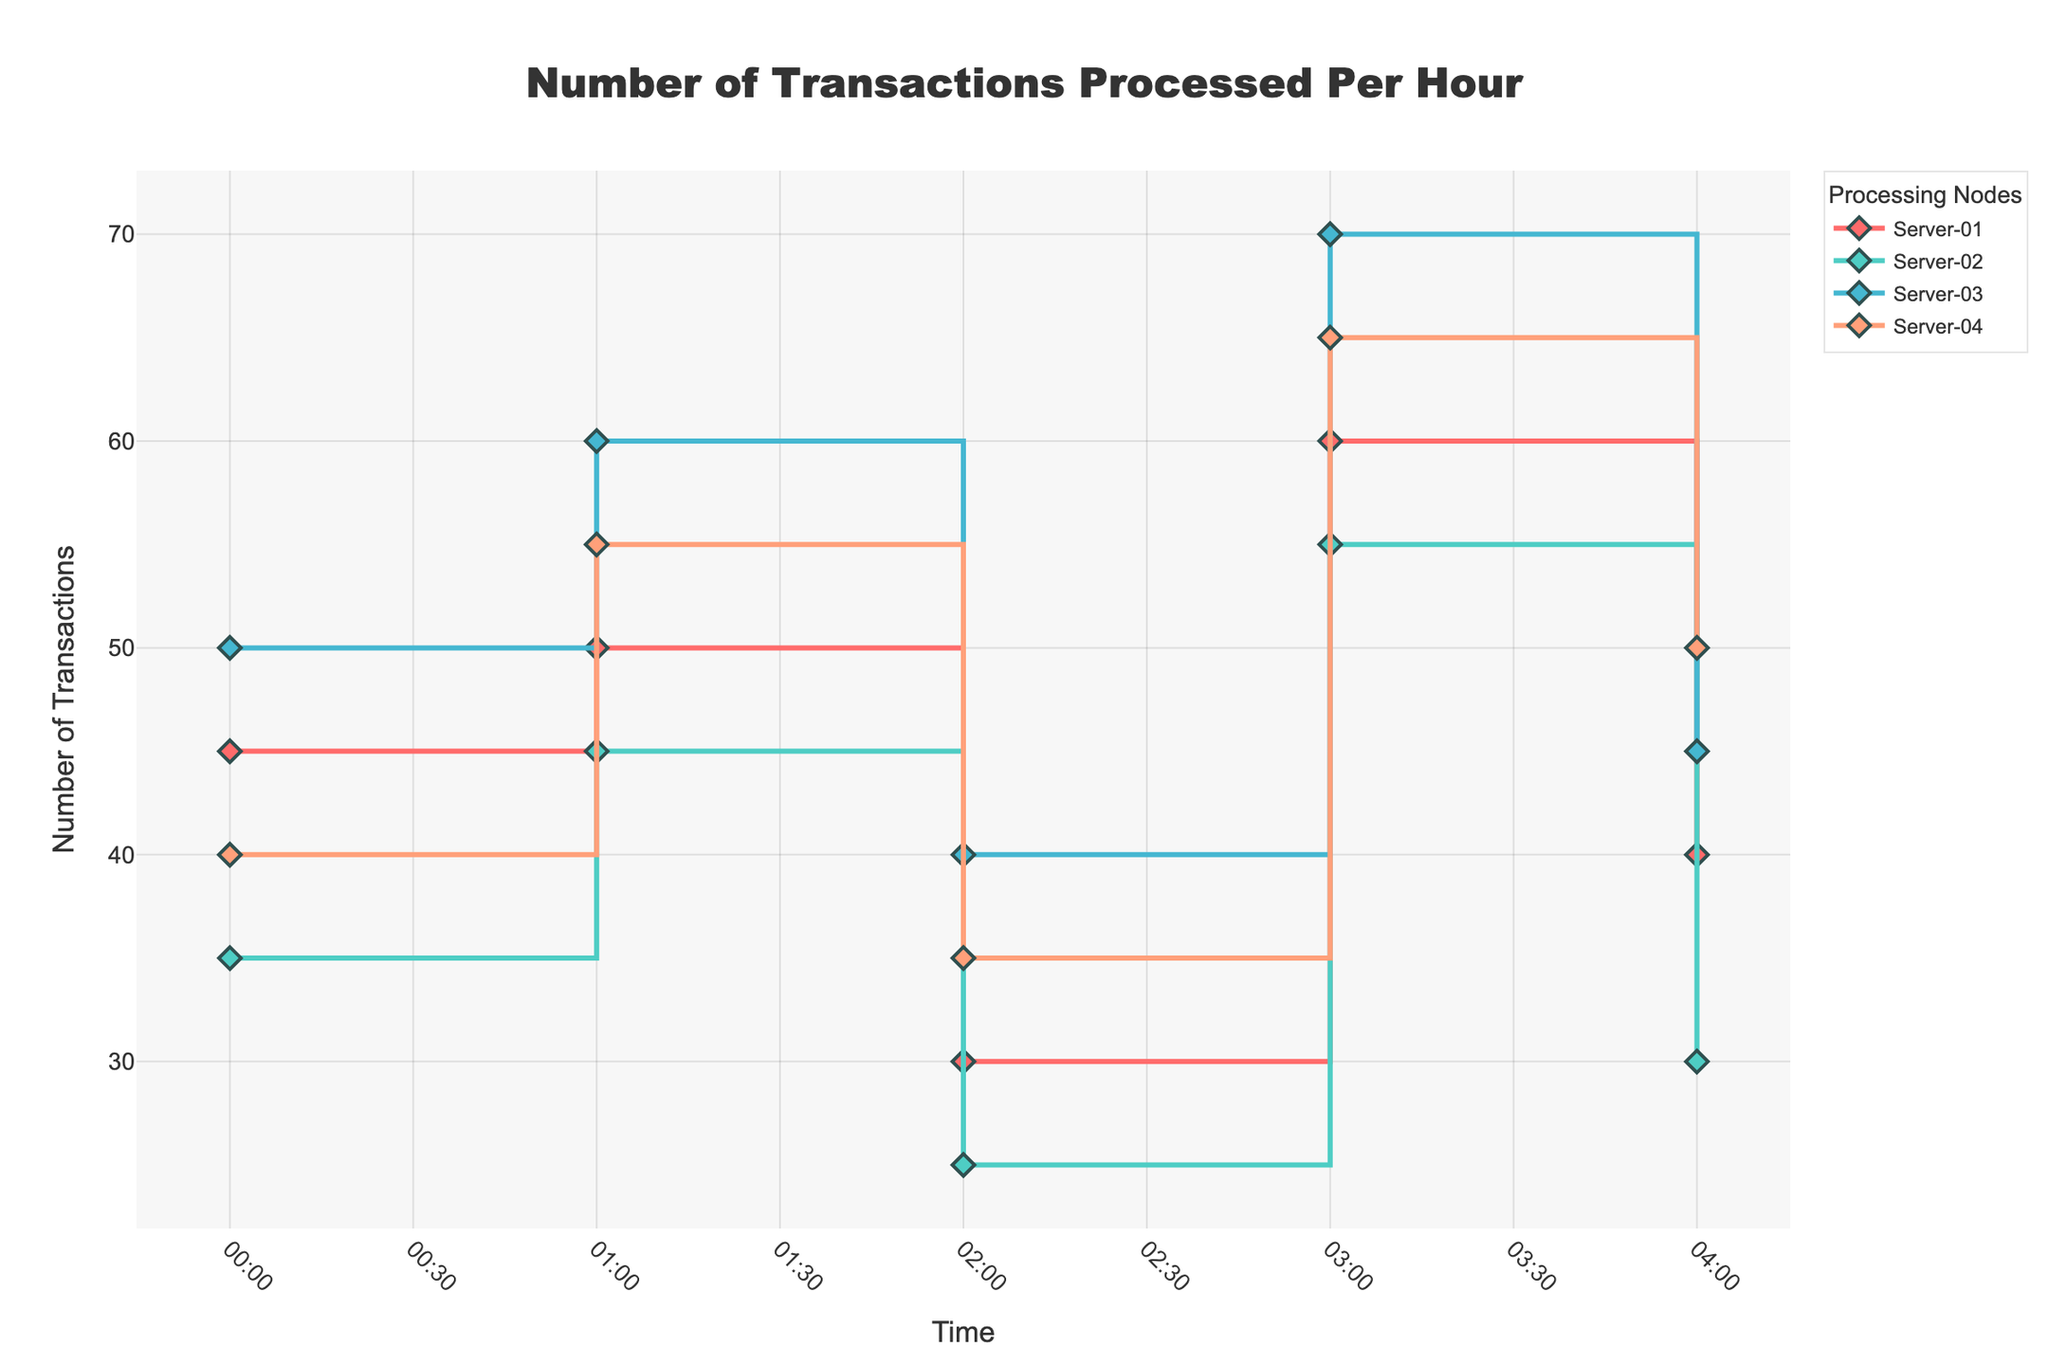What is the title of the plot? The title is displayed prominently at the top of the plot. It reads "Number of Transactions Processed Per Hour," which gives an overview of what the figure is about.
Answer: Number of Transactions Processed Per Hour Which server processed the highest number of transactions at 3 AM? At 3 AM, Server-03 has the highest number of transactions. This can be identified by finding the highest point on the chart among the values at 3 AM. Server-03 processed 70 transactions.
Answer: Server-03 How many transactions did Server-02 process at 2 AM? To find this, look at the value for Server-02 at the 2 AM mark on the x-axis. The number of transactions is represented by the y-axis. Server-02 processed 25 transactions at 2 AM.
Answer: 25 What is the average number of transactions processed per hour by Server-01 and Server-04 between 1 AM and 4 AM? Sum the transactions for each server from 1 AM to 4 AM. Server-01: 50+30+60+40=180. Server-04: 55+35+65+50=205. Average = (180 + 205) / 8 = 48.125.
Answer: 48.125 Which server shows the greatest variability in the number of transactions processed? Variability can be judged by the range or differences in heights of the "steps" in the stair plot. Server-03 shows the greatest variability, ranging from 40 transactions to 70 transactions.
Answer: Server-03 At what times do all servers experience a decrease in the number of transactions from the previous hour? Compare the number of transactions for each server hour by hour. All servers experience a drop between 3 AM and 4 AM. Server-01: 60 to 40, Server-02: 55 to 30, Server-03: 70 to 45, Server-04: 65 to 50.
Answer: Between 3 AM and 4 AM How many total transactions were processed by Server-01 from midnight to 4 AM? Sum the number of transactions for Server-01 for each hour within the given time range. That is 45+50+30+60+40 = 225 transactions.
Answer: 225 Which server has the least significant differences in the number of transactions processed over the observed period? Least significant differences imply the smallest range or variability. Server-02 processes between 25 and 55 transactions, with the differences being more moderate compared to others.
Answer: Server-02 